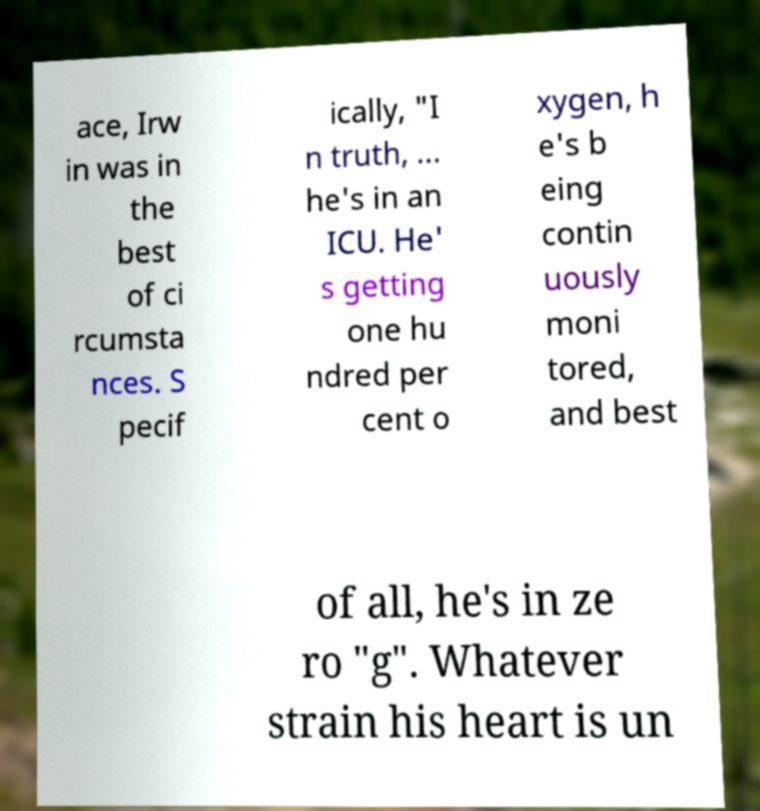Can you read and provide the text displayed in the image?This photo seems to have some interesting text. Can you extract and type it out for me? ace, Irw in was in the best of ci rcumsta nces. S pecif ically, "I n truth, ... he's in an ICU. He' s getting one hu ndred per cent o xygen, h e's b eing contin uously moni tored, and best of all, he's in ze ro "g". Whatever strain his heart is un 